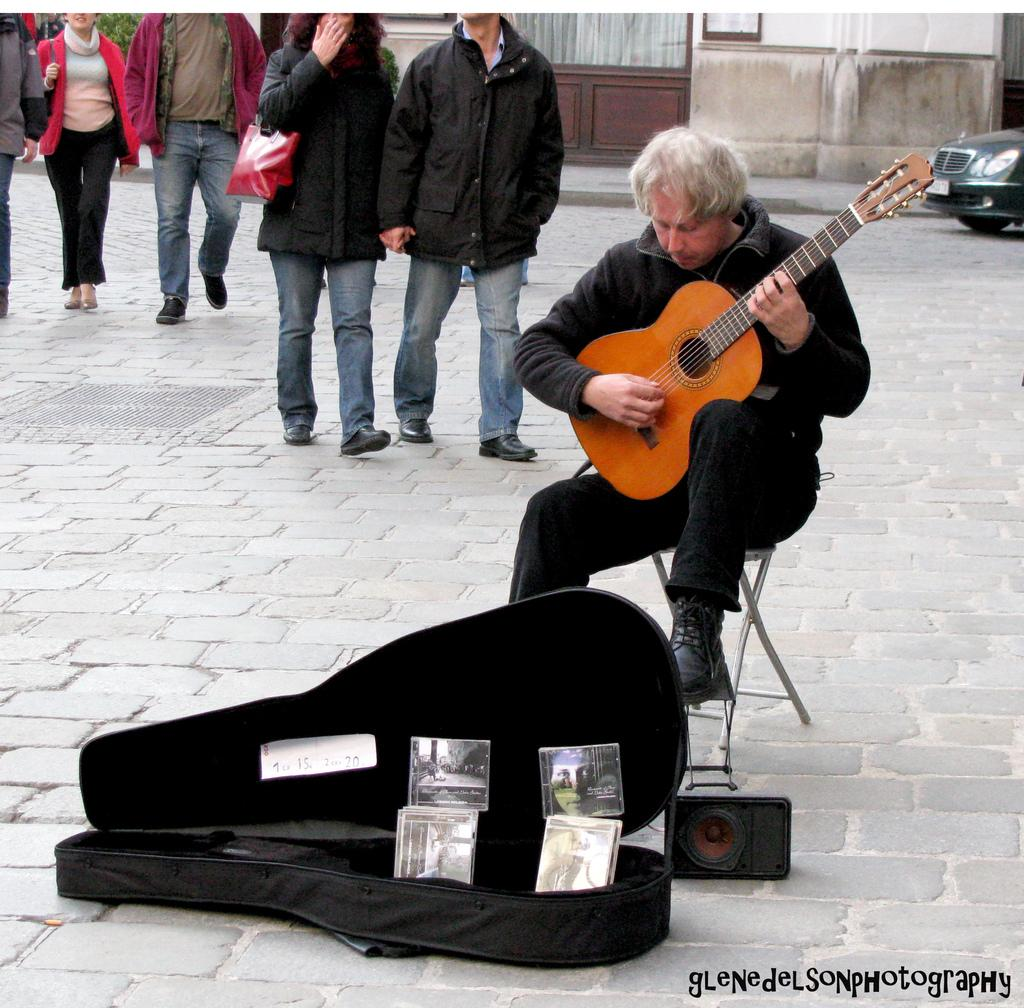What is the person in the image doing? The person is playing a guitar. What is in front of the person? There is a bag and a speaker in front of the person. What can be seen behind the person? There are people walking behind the person. What is visible in the background of the image? There is a building, a door, and a car in the background. How many pigs are visible in the image? There are no pigs present in the image. What is the aftermath of the guitar performance in the image? There is no indication of a guitar performance's aftermath in the image. 